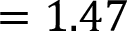Convert formula to latex. <formula><loc_0><loc_0><loc_500><loc_500>= 1 . 4 7</formula> 